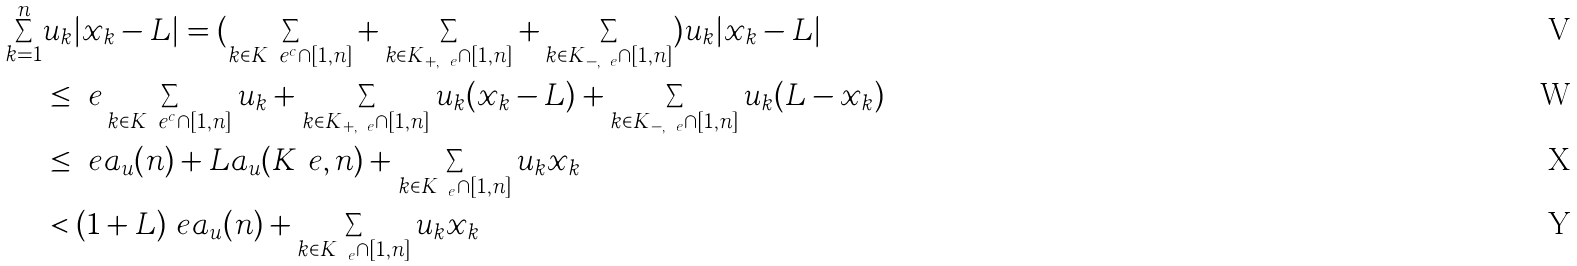Convert formula to latex. <formula><loc_0><loc_0><loc_500><loc_500>\sum _ { k = 1 } ^ { n } & u _ { k } | x _ { k } - L | = ( \sum _ { k \in K _ { \ } e ^ { c } \cap [ 1 , n ] } + \sum _ { k \in K _ { + , \ e } \cap [ 1 , n ] } + \sum _ { k \in K _ { - , \ e } \cap [ 1 , n ] } ) u _ { k } | x _ { k } - L | \\ & \leq \ e \sum _ { k \in K _ { \ } e ^ { c } \cap [ 1 , n ] } u _ { k } + \sum _ { k \in K _ { + , \ e } \cap [ 1 , n ] } u _ { k } ( x _ { k } - L ) + \sum _ { k \in K _ { - , \ e } \cap [ 1 , n ] } u _ { k } ( L - x _ { k } ) \\ & \leq \ e a _ { u } ( n ) + L a _ { u } ( K _ { \ } e , n ) + \sum _ { k \in K _ { \ e } \cap [ 1 , n ] } u _ { k } x _ { k } \\ & < ( 1 + L ) \ e a _ { u } ( n ) + \sum _ { k \in K _ { \ e } \cap [ 1 , n ] } u _ { k } x _ { k }</formula> 